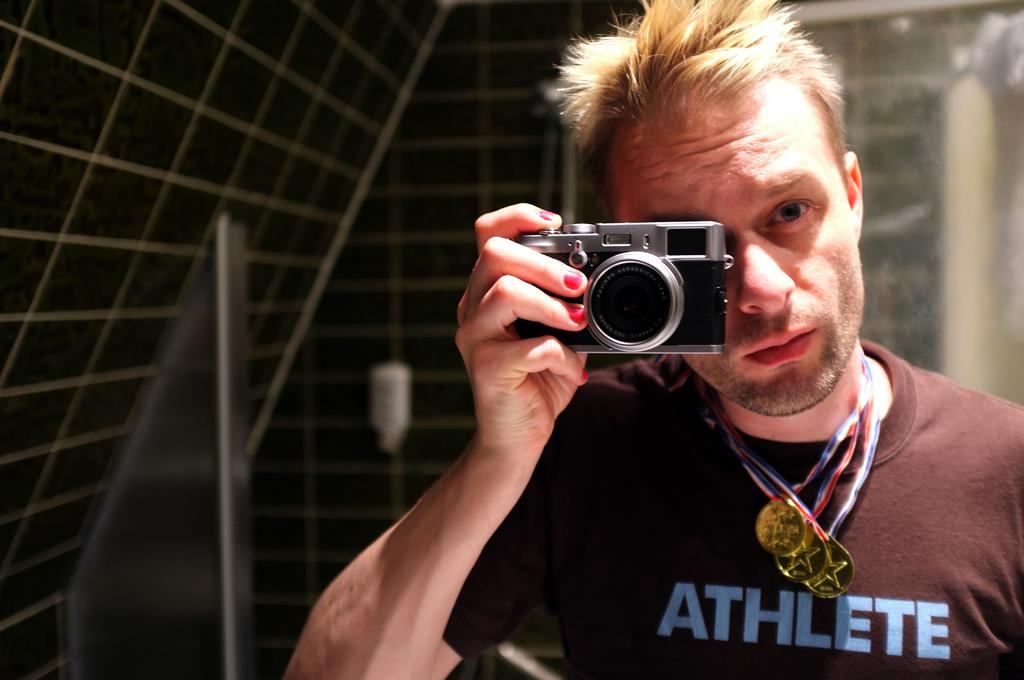Who is the main subject in the image? There is a man in the image. What is the man holding in the image? The man is holding a camera. Can you describe any additional details about the man? The man has medals around his neck. What type of parcel is the man holding in the image? There is no parcel present in the image; the man is holding a camera. Can you describe the self-awareness of the man in the image? The image does not provide any information about the man's self-awareness. 